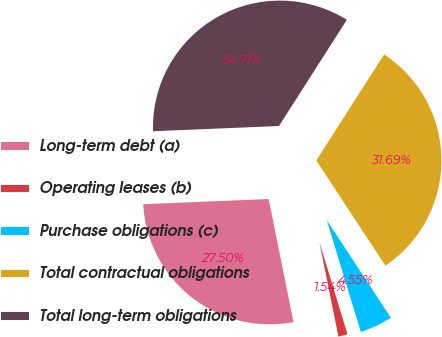Convert chart to OTSL. <chart><loc_0><loc_0><loc_500><loc_500><pie_chart><fcel>Long-term debt (a)<fcel>Operating leases (b)<fcel>Purchase obligations (c)<fcel>Total contractual obligations<fcel>Total long-term obligations<nl><fcel>27.5%<fcel>1.54%<fcel>4.55%<fcel>31.69%<fcel>34.71%<nl></chart> 